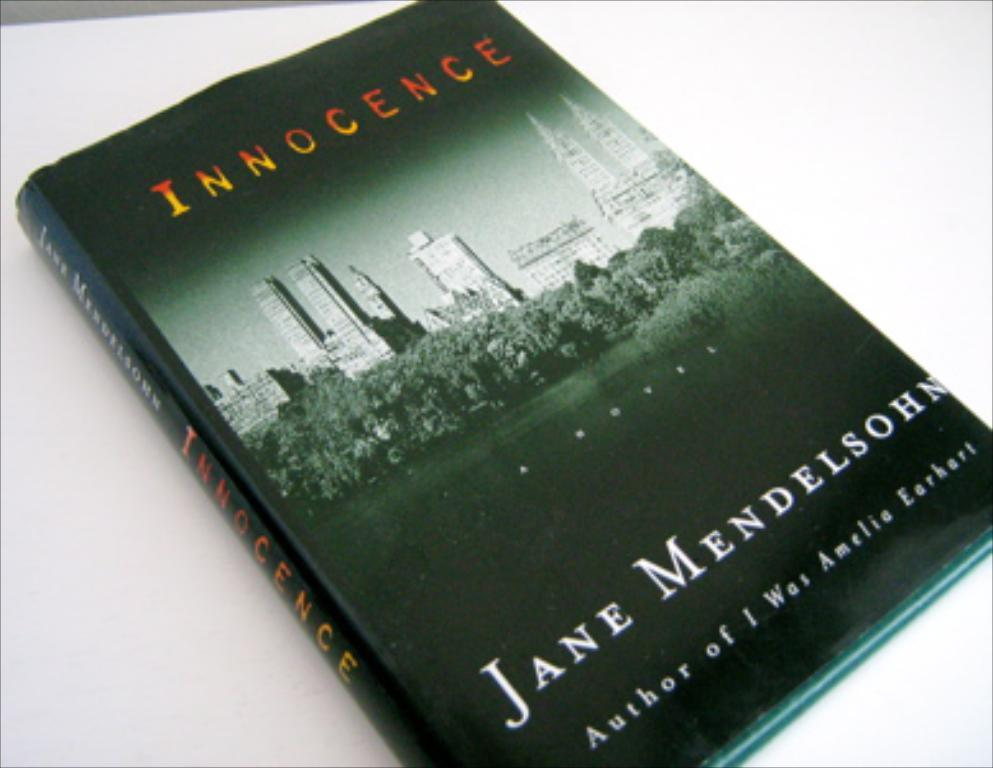<image>
Write a terse but informative summary of the picture. A cover for the book Innocence written by Jane Mendelsohn. 